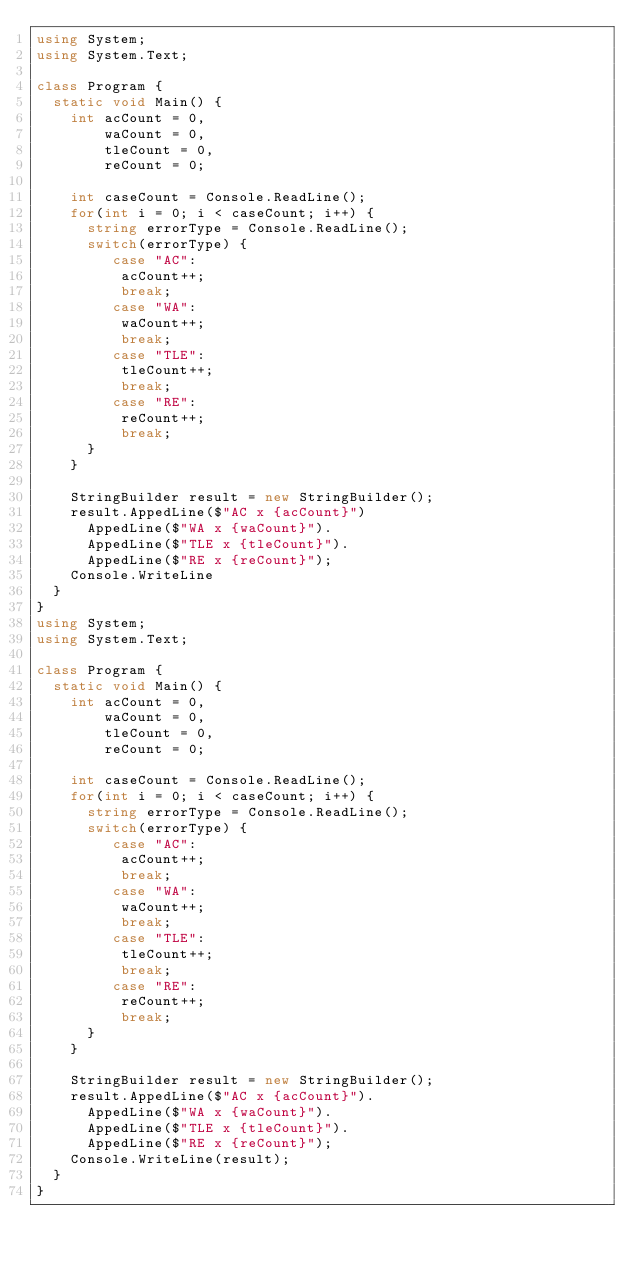Convert code to text. <code><loc_0><loc_0><loc_500><loc_500><_C#_>using System;
using System.Text;
 
class Program {
  static void Main() {
    int acCount = 0,
        waCount = 0,
        tleCount = 0,
        reCount = 0;
    
    int caseCount = Console.ReadLine();
    for(int i = 0; i < caseCount; i++) {
      string errorType = Console.ReadLine();
      switch(errorType) {
         case "AC":
          acCount++;
          break;
         case "WA":
          waCount++;
          break;
         case "TLE":
          tleCount++;
          break;
         case "RE":
          reCount++;
          break;
      }
    }
    
    StringBuilder result = new StringBuilder();
    result.AppedLine($"AC x {acCount}")
      AppedLine($"WA x {waCount}").
      AppedLine($"TLE x {tleCount}").
      AppedLine($"RE x {reCount}");
    Console.WriteLine
  }
}
using System;
using System.Text;
 
class Program {
  static void Main() {
    int acCount = 0,
        waCount = 0,
        tleCount = 0,
        reCount = 0;
    
    int caseCount = Console.ReadLine();
    for(int i = 0; i < caseCount; i++) {
      string errorType = Console.ReadLine();
      switch(errorType) {
         case "AC":
          acCount++;
          break;
         case "WA":
          waCount++;
          break;
         case "TLE":
          tleCount++;
          break;
         case "RE":
          reCount++;
          break;
      }
    }
    
    StringBuilder result = new StringBuilder();
    result.AppedLine($"AC x {acCount}").
      AppedLine($"WA x {waCount}").
      AppedLine($"TLE x {tleCount}").
      AppedLine($"RE x {reCount}");
    Console.WriteLine(result);
  }
}
</code> 